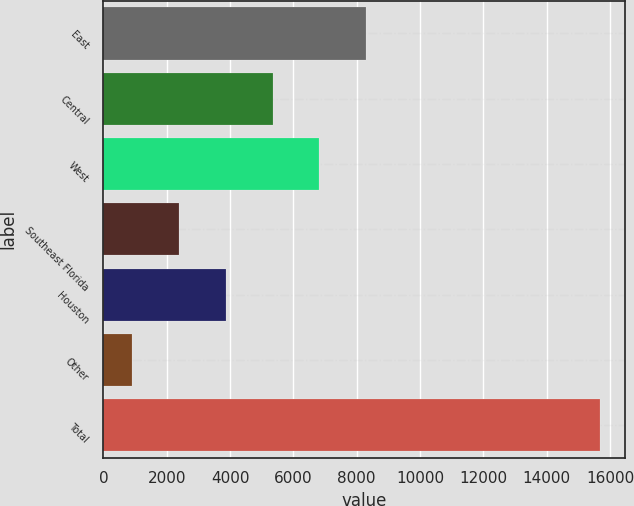Convert chart. <chart><loc_0><loc_0><loc_500><loc_500><bar_chart><fcel>East<fcel>Central<fcel>West<fcel>Southeast Florida<fcel>Houston<fcel>Other<fcel>Total<nl><fcel>8298<fcel>5343.6<fcel>6820.8<fcel>2389.2<fcel>3866.4<fcel>912<fcel>15684<nl></chart> 